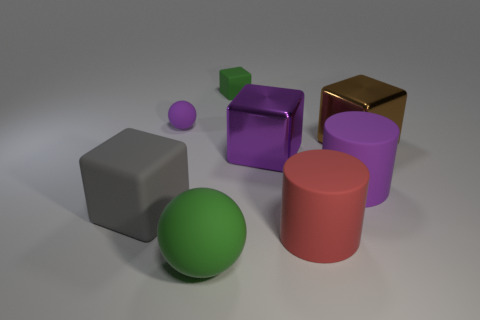What is the size of the thing that is the same color as the small rubber cube?
Provide a short and direct response. Large. What number of tiny rubber blocks are the same color as the large rubber sphere?
Offer a terse response. 1. What is the shape of the purple rubber object to the right of the matte ball that is in front of the tiny rubber ball?
Provide a succinct answer. Cylinder. How many other things are the same shape as the red rubber thing?
Make the answer very short. 1. How big is the object left of the tiny thing that is left of the tiny green matte thing?
Make the answer very short. Large. Are there any big blue cylinders?
Offer a very short reply. No. How many big brown cubes are to the right of the sphere that is behind the gray block?
Your response must be concise. 1. There is a purple thing that is on the right side of the big red cylinder; what is its shape?
Offer a terse response. Cylinder. There is a purple cylinder that is in front of the small rubber thing that is on the right side of the purple rubber thing left of the red cylinder; what is it made of?
Your response must be concise. Rubber. What number of other things are there of the same size as the red rubber cylinder?
Your answer should be compact. 5. 